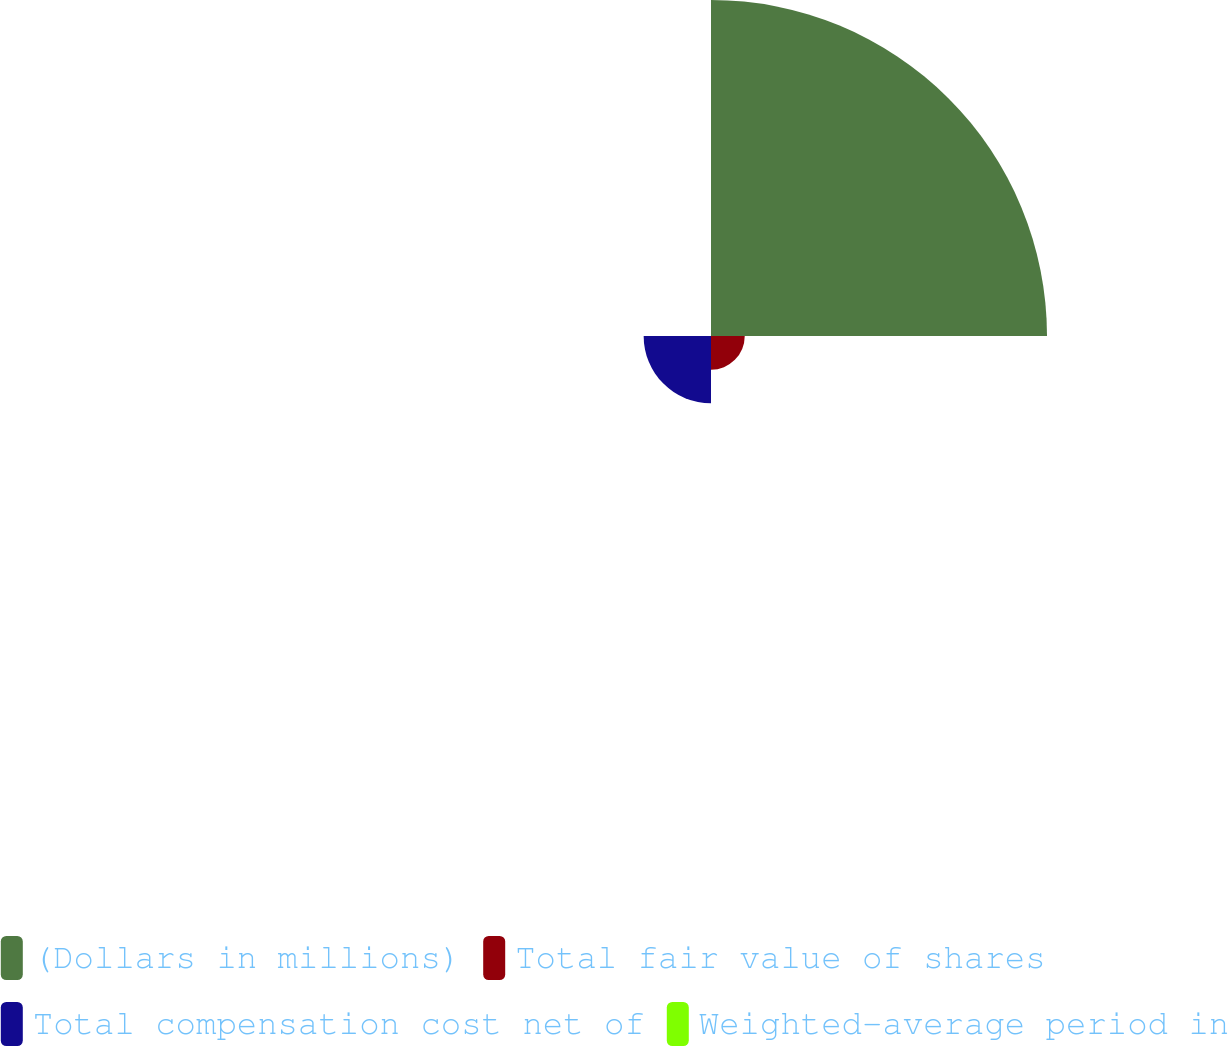<chart> <loc_0><loc_0><loc_500><loc_500><pie_chart><fcel>(Dollars in millions)<fcel>Total fair value of shares<fcel>Total compensation cost net of<fcel>Weighted-average period in<nl><fcel>76.84%<fcel>7.72%<fcel>15.4%<fcel>0.04%<nl></chart> 